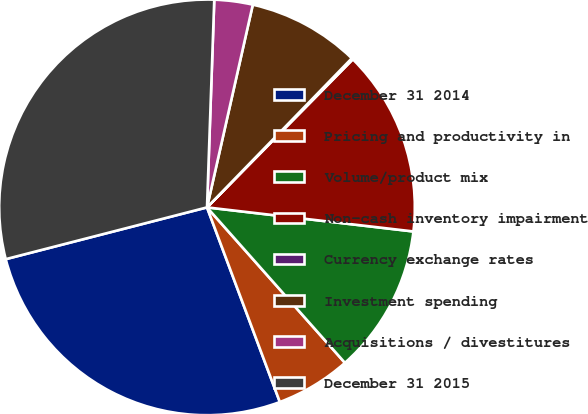<chart> <loc_0><loc_0><loc_500><loc_500><pie_chart><fcel>December 31 2014<fcel>Pricing and productivity in<fcel>Volume/product mix<fcel>Non-cash inventory impairment<fcel>Currency exchange rates<fcel>Investment spending<fcel>Acquisitions / divestitures<fcel>December 31 2015<nl><fcel>26.69%<fcel>5.85%<fcel>11.6%<fcel>14.47%<fcel>0.11%<fcel>8.73%<fcel>2.98%<fcel>29.56%<nl></chart> 